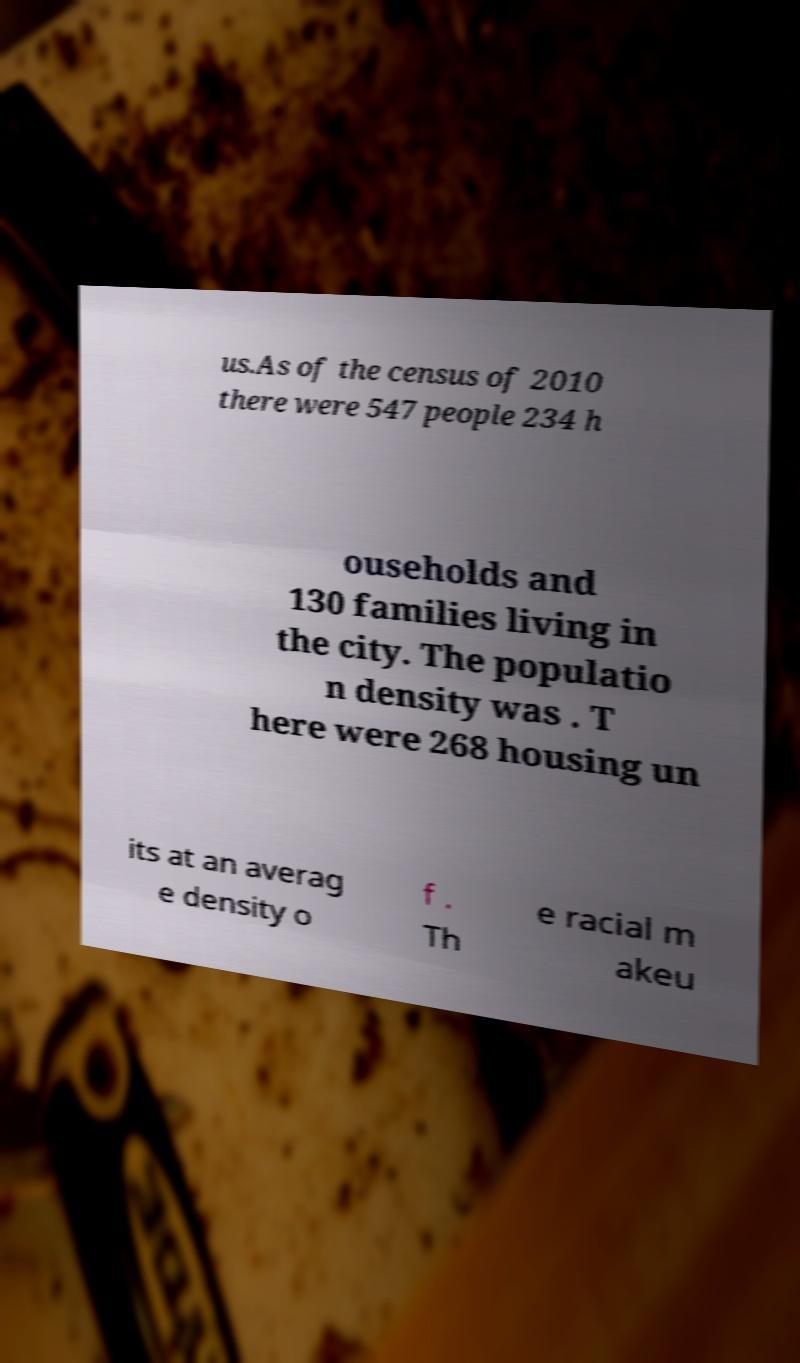Can you read and provide the text displayed in the image?This photo seems to have some interesting text. Can you extract and type it out for me? us.As of the census of 2010 there were 547 people 234 h ouseholds and 130 families living in the city. The populatio n density was . T here were 268 housing un its at an averag e density o f . Th e racial m akeu 